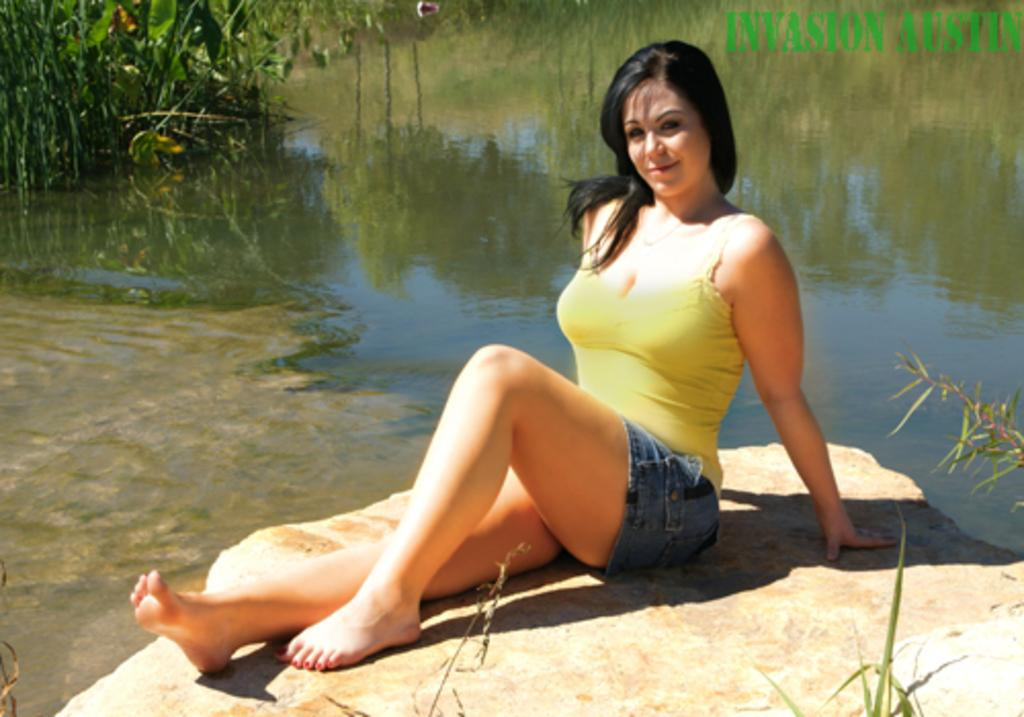What is the main subject of the subject of the image? There is a beautiful woman in the image. What is the woman sitting on? The woman is sitting on a stone. What color is the woman's top? The woman is wearing a yellow top. What type of bottoms is the woman wearing? The woman is wearing jeans shorts. What can be seen in the background of the image? There is water visible in the image, and there are trees on the left side of the image. What type of cap is the woman wearing in the image? There is no cap visible in the image; the woman is wearing a yellow top and jeans shorts. What type of flesh can be seen in the image? There is no flesh visible in the image; the woman is fully clothed in a yellow top and jeans shorts. 